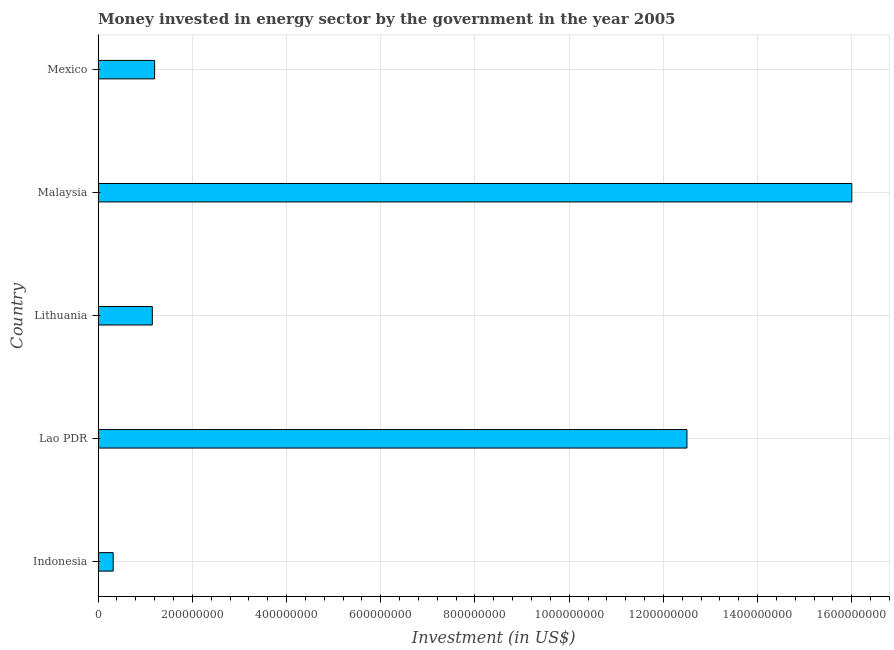What is the title of the graph?
Provide a short and direct response. Money invested in energy sector by the government in the year 2005. What is the label or title of the X-axis?
Make the answer very short. Investment (in US$). What is the label or title of the Y-axis?
Keep it short and to the point. Country. What is the investment in energy in Lao PDR?
Keep it short and to the point. 1.25e+09. Across all countries, what is the maximum investment in energy?
Keep it short and to the point. 1.60e+09. Across all countries, what is the minimum investment in energy?
Offer a terse response. 3.20e+07. In which country was the investment in energy maximum?
Provide a succinct answer. Malaysia. In which country was the investment in energy minimum?
Keep it short and to the point. Indonesia. What is the sum of the investment in energy?
Provide a succinct answer. 3.12e+09. What is the difference between the investment in energy in Lithuania and Mexico?
Offer a terse response. -5.00e+06. What is the average investment in energy per country?
Make the answer very short. 6.23e+08. What is the median investment in energy?
Make the answer very short. 1.20e+08. In how many countries, is the investment in energy greater than 1040000000 US$?
Offer a terse response. 2. What is the ratio of the investment in energy in Lao PDR to that in Mexico?
Provide a succinct answer. 10.42. Is the difference between the investment in energy in Indonesia and Malaysia greater than the difference between any two countries?
Your answer should be very brief. Yes. What is the difference between the highest and the second highest investment in energy?
Provide a short and direct response. 3.50e+08. Is the sum of the investment in energy in Indonesia and Malaysia greater than the maximum investment in energy across all countries?
Your response must be concise. Yes. What is the difference between the highest and the lowest investment in energy?
Provide a short and direct response. 1.57e+09. Are all the bars in the graph horizontal?
Offer a very short reply. Yes. What is the difference between two consecutive major ticks on the X-axis?
Offer a terse response. 2.00e+08. Are the values on the major ticks of X-axis written in scientific E-notation?
Your response must be concise. No. What is the Investment (in US$) of Indonesia?
Offer a terse response. 3.20e+07. What is the Investment (in US$) in Lao PDR?
Give a very brief answer. 1.25e+09. What is the Investment (in US$) in Lithuania?
Make the answer very short. 1.15e+08. What is the Investment (in US$) in Malaysia?
Keep it short and to the point. 1.60e+09. What is the Investment (in US$) in Mexico?
Your answer should be compact. 1.20e+08. What is the difference between the Investment (in US$) in Indonesia and Lao PDR?
Offer a very short reply. -1.22e+09. What is the difference between the Investment (in US$) in Indonesia and Lithuania?
Give a very brief answer. -8.30e+07. What is the difference between the Investment (in US$) in Indonesia and Malaysia?
Your answer should be very brief. -1.57e+09. What is the difference between the Investment (in US$) in Indonesia and Mexico?
Your response must be concise. -8.80e+07. What is the difference between the Investment (in US$) in Lao PDR and Lithuania?
Keep it short and to the point. 1.14e+09. What is the difference between the Investment (in US$) in Lao PDR and Malaysia?
Your answer should be very brief. -3.50e+08. What is the difference between the Investment (in US$) in Lao PDR and Mexico?
Your response must be concise. 1.13e+09. What is the difference between the Investment (in US$) in Lithuania and Malaysia?
Provide a short and direct response. -1.48e+09. What is the difference between the Investment (in US$) in Lithuania and Mexico?
Your answer should be compact. -5.00e+06. What is the difference between the Investment (in US$) in Malaysia and Mexico?
Your answer should be very brief. 1.48e+09. What is the ratio of the Investment (in US$) in Indonesia to that in Lao PDR?
Make the answer very short. 0.03. What is the ratio of the Investment (in US$) in Indonesia to that in Lithuania?
Give a very brief answer. 0.28. What is the ratio of the Investment (in US$) in Indonesia to that in Malaysia?
Give a very brief answer. 0.02. What is the ratio of the Investment (in US$) in Indonesia to that in Mexico?
Ensure brevity in your answer.  0.27. What is the ratio of the Investment (in US$) in Lao PDR to that in Lithuania?
Give a very brief answer. 10.87. What is the ratio of the Investment (in US$) in Lao PDR to that in Malaysia?
Provide a succinct answer. 0.78. What is the ratio of the Investment (in US$) in Lao PDR to that in Mexico?
Keep it short and to the point. 10.42. What is the ratio of the Investment (in US$) in Lithuania to that in Malaysia?
Ensure brevity in your answer.  0.07. What is the ratio of the Investment (in US$) in Lithuania to that in Mexico?
Make the answer very short. 0.96. What is the ratio of the Investment (in US$) in Malaysia to that in Mexico?
Offer a very short reply. 13.33. 